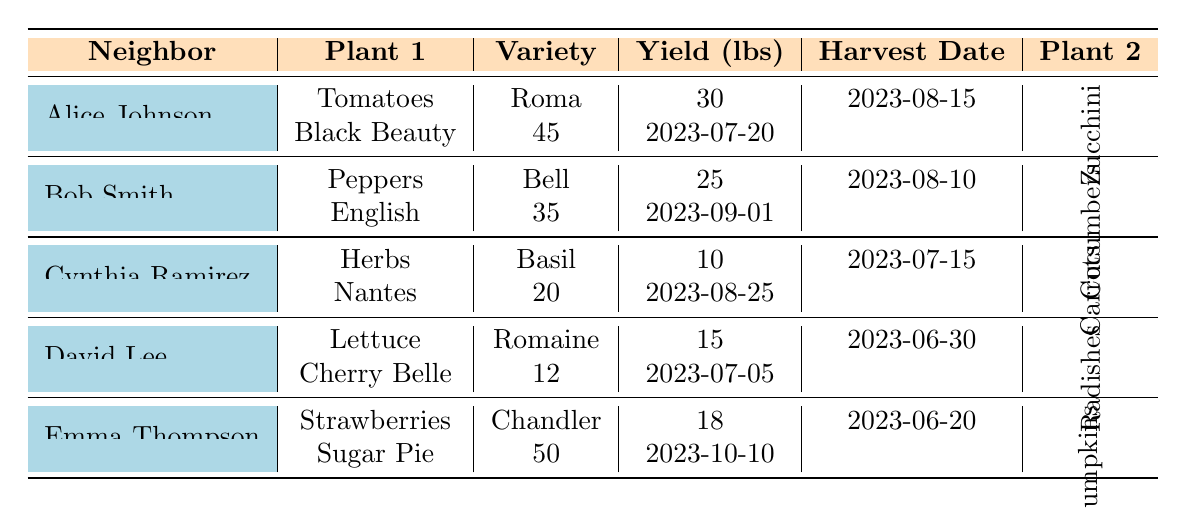What are the two plants grown by Alice Johnson? The table shows that Alice Johnson grew Tomatoes and Zucchini.
Answer: Tomatoes and Zucchini What was the yield of Bob Smith's Cucumbers? The table indicates that Bob Smith's Cucumbers had a yield of 35 lbs.
Answer: 35 lbs Which neighbor had the highest yield for a single plant? Looking at the yields, Emma Thompson had the highest yield with her Pumpkins, which produced 50 lbs.
Answer: Emma Thompson How many pounds of vegetables did Cynthia Ramirez grow in total? Cynthia Ramirez grew 10 lbs of Herbs and 20 lbs of Carrots; thus, the total is 10 + 20 = 30 lbs.
Answer: 30 lbs Did David Lee harvest Radishes before he harvested Lettuce? According to the table, David Lee harvested Lettuce on June 30 and Radishes on July 5, so he did not harvest Radishes before Lettuce.
Answer: No Which variety of Tomato did Alice Johnson grow? The table specifies that Alice Johnson grew Roma Tomatoes.
Answer: Roma What is the average yield of all the plants grown by Emma Thompson? Emma Thompson's yields were 18 lbs (Strawberries) and 50 lbs (Pumpkins). The average is (18 + 50) / 2 = 34 lbs.
Answer: 34 lbs Who grew more weight in vegetables, Bob Smith or David Lee? Bob Smith had 25 lbs of Peppers and 35 lbs of Cucumbers (total 60 lbs), while David Lee had 15 lbs of Lettuce and 12 lbs of Radishes (total 27 lbs). Therefore, Bob Smith grew more.
Answer: Bob Smith Which plant variety yielded the least weight among all neighbors? The lowest yield recorded is 10 lbs for Basil, grown by Cynthia Ramirez.
Answer: Basil In terms of harvest date, who harvested their plants earliest? Comparing the harvest dates, Emma Thompson harvested Strawberries on June 20, which is earlier than others.
Answer: Emma Thompson 